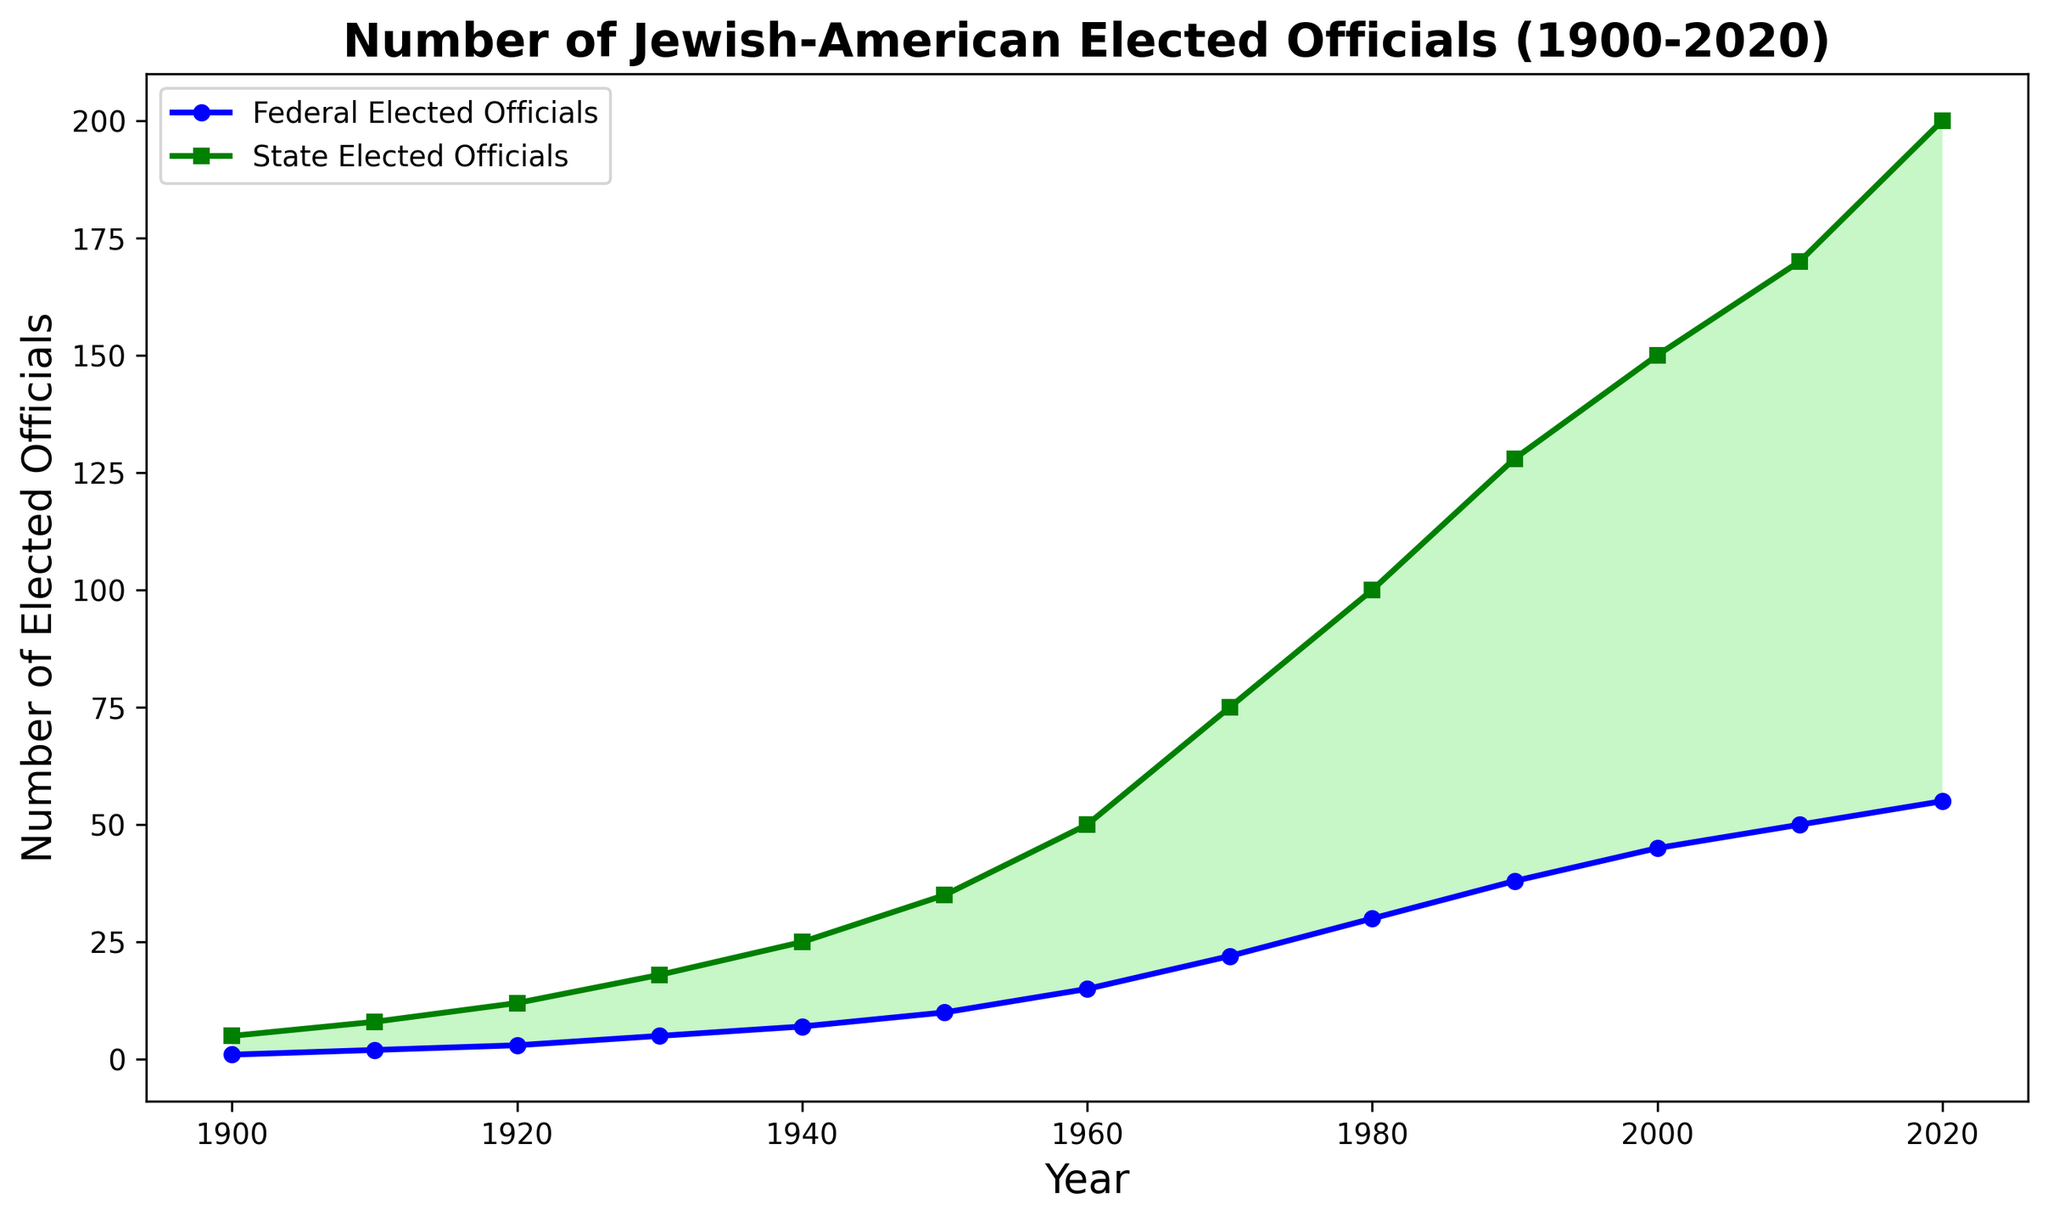Which year had the highest number of Jewish-American state elected officials? The peak of state elected officials was reached in 2020 as indicated by the highest point on the green line.
Answer: 2020 How did the number of federal elected officials change from 1900 to 1950? In 1900, there was 1 federal official, and by 1950, this had increased to 10, showing a steady rise over 50 years.
Answer: Increased by 9 Which level of elected officials saw a greater increase from 1960 to 1980? Federal officials increased from 15 to 30 (an increase of 15), while state officials increased from 50 to 100 (an increase of 50). Thus, the increase in state officials is greater.
Answer: State What is the total number of officials at both levels in the year 2000? In 2000, there were 45 federal and 150 state officials. The sum is 45 + 150 = 195.
Answer: 195 What color is used to fill the area where the number of state officials is greater than the number of federal officials? The area where state officials exceed federal officials is shaded light green.
Answer: Light green In which decade did the number of federal elected officials first exceed 20? The line representing federal officials first crosses the 20 mark in the 1970s.
Answer: 1970s Between which two consecutive decades did federal officials see their largest increase? The largest increase is observed between 1950 (10 officials) and 1960 (15 officials), which is an increase of 5.
Answer: 1950-1960 How many more state officials were there than federal officials in 1940? In 1940, there were 7 federal and 25 state officials. The difference is 25 - 7 = 18.
Answer: 18 What is the average number of federal elected officials from 1900 to 2020? To find the average number of federal officials over the years, sum all the federal officials from 1900 to 2020 and divide by the number of years: (1+2+3+5+7+10+15+22+30+38+45+50+55)/13 ≈ 23.
Answer: 23 When did the number of state elected officials first reach 100? The green line first touches the 100 mark in the 1980s according to the plot.
Answer: 1980s 